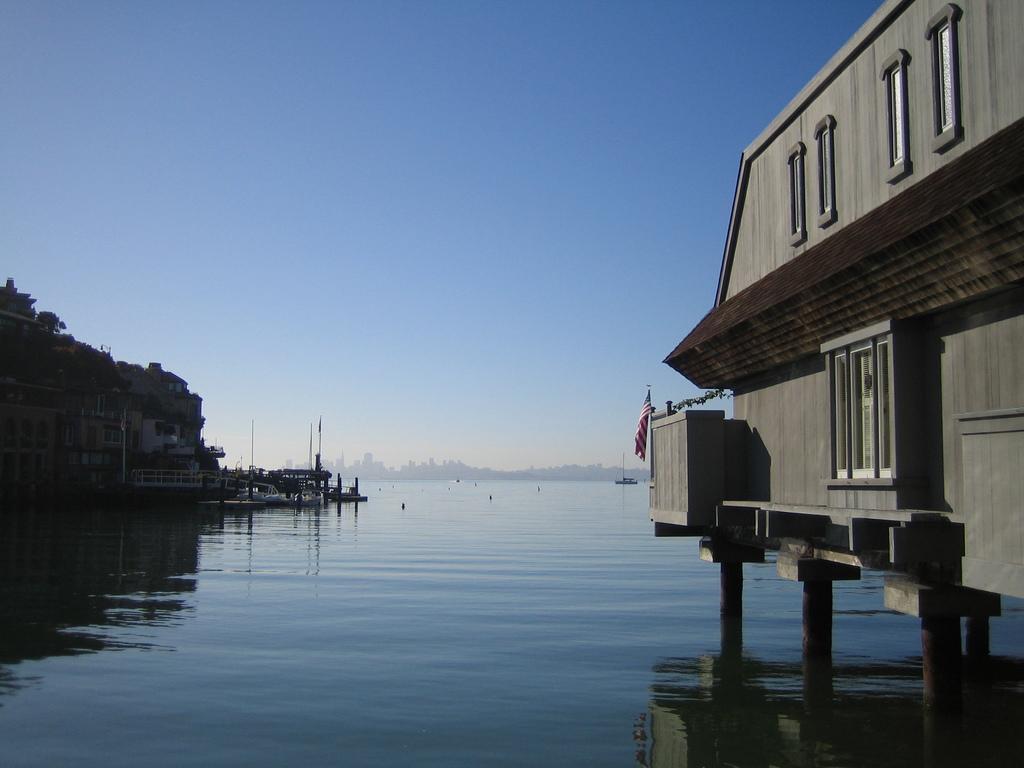Describe this image in one or two sentences. On the right side of the image we can see flag and house on the water. On the left side of the image we can see hill, houses and boats. In the background we can see water, buildings and sky. 